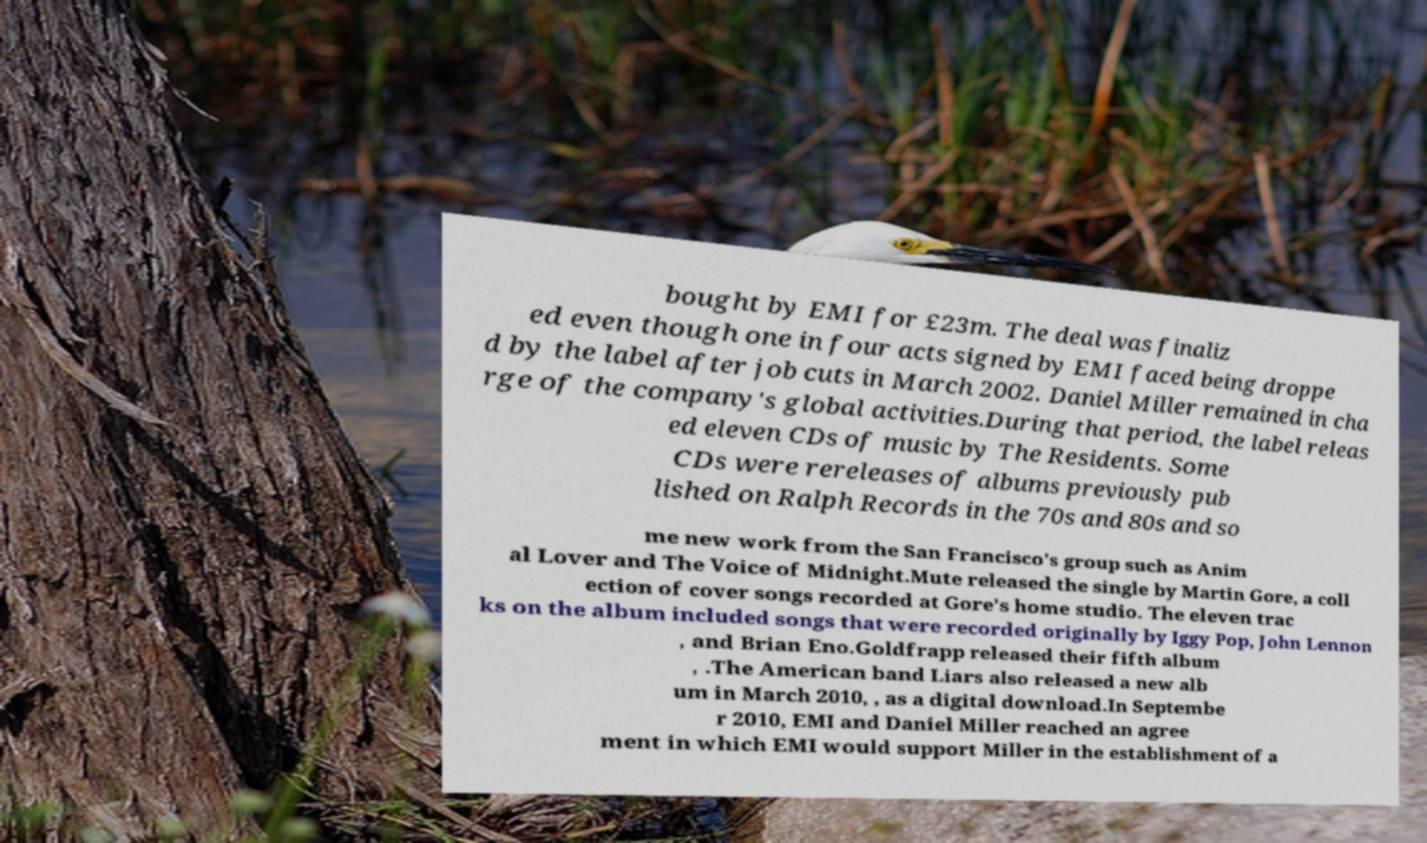There's text embedded in this image that I need extracted. Can you transcribe it verbatim? bought by EMI for £23m. The deal was finaliz ed even though one in four acts signed by EMI faced being droppe d by the label after job cuts in March 2002. Daniel Miller remained in cha rge of the company's global activities.During that period, the label releas ed eleven CDs of music by The Residents. Some CDs were rereleases of albums previously pub lished on Ralph Records in the 70s and 80s and so me new work from the San Francisco's group such as Anim al Lover and The Voice of Midnight.Mute released the single by Martin Gore, a coll ection of cover songs recorded at Gore's home studio. The eleven trac ks on the album included songs that were recorded originally by Iggy Pop, John Lennon , and Brian Eno.Goldfrapp released their fifth album , .The American band Liars also released a new alb um in March 2010, , as a digital download.In Septembe r 2010, EMI and Daniel Miller reached an agree ment in which EMI would support Miller in the establishment of a 